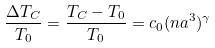Convert formula to latex. <formula><loc_0><loc_0><loc_500><loc_500>\frac { \Delta T _ { C } } { T _ { 0 } } = \frac { T _ { C } - T _ { 0 } } { T _ { 0 } } = c _ { 0 } ( n a ^ { 3 } ) ^ { \gamma }</formula> 